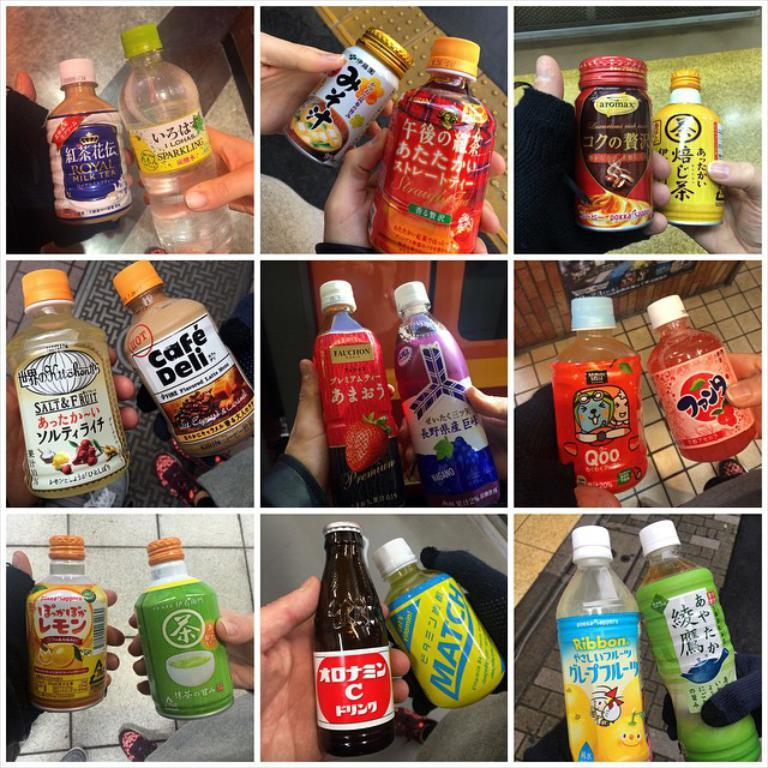<image>
Give a short and clear explanation of the subsequent image. Bottles of liquids are shown including many with Asian writing and one called Cafe Deli. 